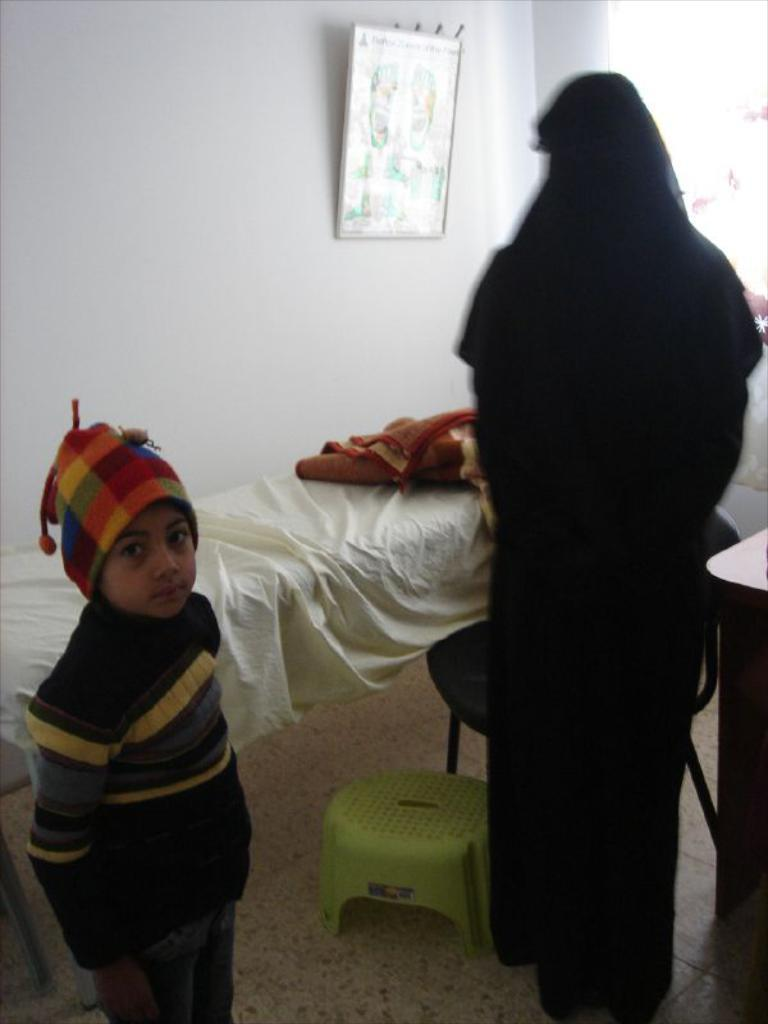Who can be seen in the image? There is a child and a woman in the image. What are the child and woman doing in the image? Both the child and woman are standing on the floor. What can be seen in the background of the image? There is a wall hanging, a cot, a chair, a table, and a blanket in the background. What type of skirt is the sun wearing in the image? There is no sun or skirt present in the image. How many plates are visible on the table in the image? There is no plate visible in the image; only a blanket, a cot, a chair, and a table are present in the background. 